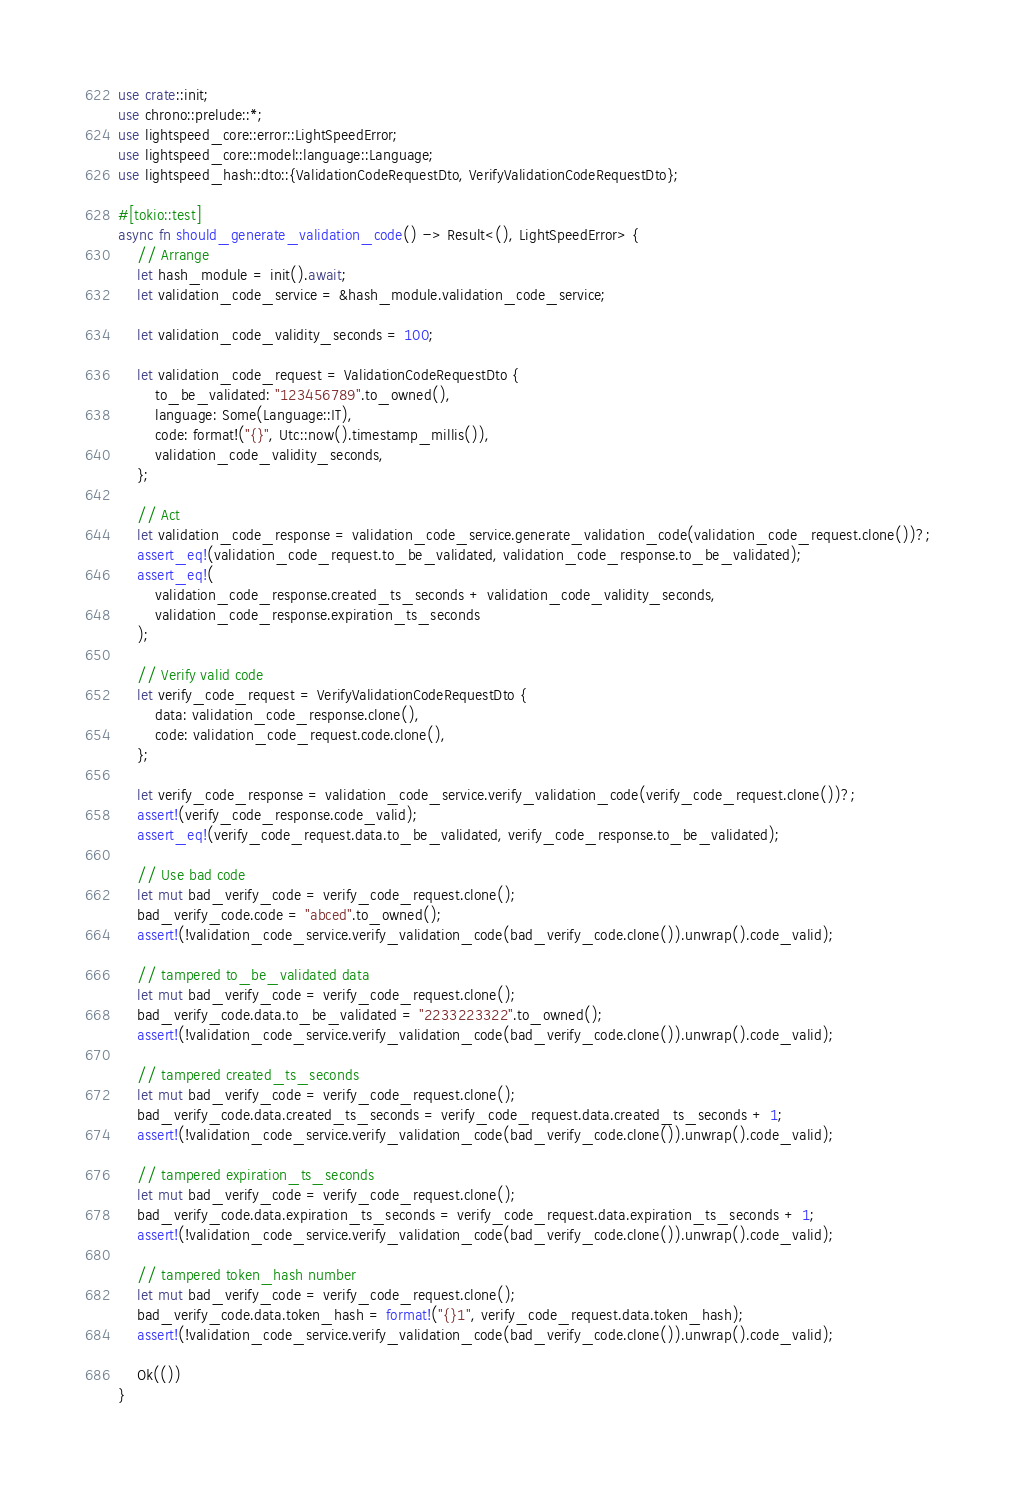Convert code to text. <code><loc_0><loc_0><loc_500><loc_500><_Rust_>use crate::init;
use chrono::prelude::*;
use lightspeed_core::error::LightSpeedError;
use lightspeed_core::model::language::Language;
use lightspeed_hash::dto::{ValidationCodeRequestDto, VerifyValidationCodeRequestDto};

#[tokio::test]
async fn should_generate_validation_code() -> Result<(), LightSpeedError> {
    // Arrange
    let hash_module = init().await;
    let validation_code_service = &hash_module.validation_code_service;

    let validation_code_validity_seconds = 100;

    let validation_code_request = ValidationCodeRequestDto {
        to_be_validated: "123456789".to_owned(),
        language: Some(Language::IT),
        code: format!("{}", Utc::now().timestamp_millis()),
        validation_code_validity_seconds,
    };

    // Act
    let validation_code_response = validation_code_service.generate_validation_code(validation_code_request.clone())?;
    assert_eq!(validation_code_request.to_be_validated, validation_code_response.to_be_validated);
    assert_eq!(
        validation_code_response.created_ts_seconds + validation_code_validity_seconds,
        validation_code_response.expiration_ts_seconds
    );

    // Verify valid code
    let verify_code_request = VerifyValidationCodeRequestDto {
        data: validation_code_response.clone(),
        code: validation_code_request.code.clone(),
    };

    let verify_code_response = validation_code_service.verify_validation_code(verify_code_request.clone())?;
    assert!(verify_code_response.code_valid);
    assert_eq!(verify_code_request.data.to_be_validated, verify_code_response.to_be_validated);

    // Use bad code
    let mut bad_verify_code = verify_code_request.clone();
    bad_verify_code.code = "abced".to_owned();
    assert!(!validation_code_service.verify_validation_code(bad_verify_code.clone()).unwrap().code_valid);

    // tampered to_be_validated data
    let mut bad_verify_code = verify_code_request.clone();
    bad_verify_code.data.to_be_validated = "2233223322".to_owned();
    assert!(!validation_code_service.verify_validation_code(bad_verify_code.clone()).unwrap().code_valid);

    // tampered created_ts_seconds
    let mut bad_verify_code = verify_code_request.clone();
    bad_verify_code.data.created_ts_seconds = verify_code_request.data.created_ts_seconds + 1;
    assert!(!validation_code_service.verify_validation_code(bad_verify_code.clone()).unwrap().code_valid);

    // tampered expiration_ts_seconds
    let mut bad_verify_code = verify_code_request.clone();
    bad_verify_code.data.expiration_ts_seconds = verify_code_request.data.expiration_ts_seconds + 1;
    assert!(!validation_code_service.verify_validation_code(bad_verify_code.clone()).unwrap().code_valid);

    // tampered token_hash number
    let mut bad_verify_code = verify_code_request.clone();
    bad_verify_code.data.token_hash = format!("{}1", verify_code_request.data.token_hash);
    assert!(!validation_code_service.verify_validation_code(bad_verify_code.clone()).unwrap().code_valid);

    Ok(())
}
</code> 